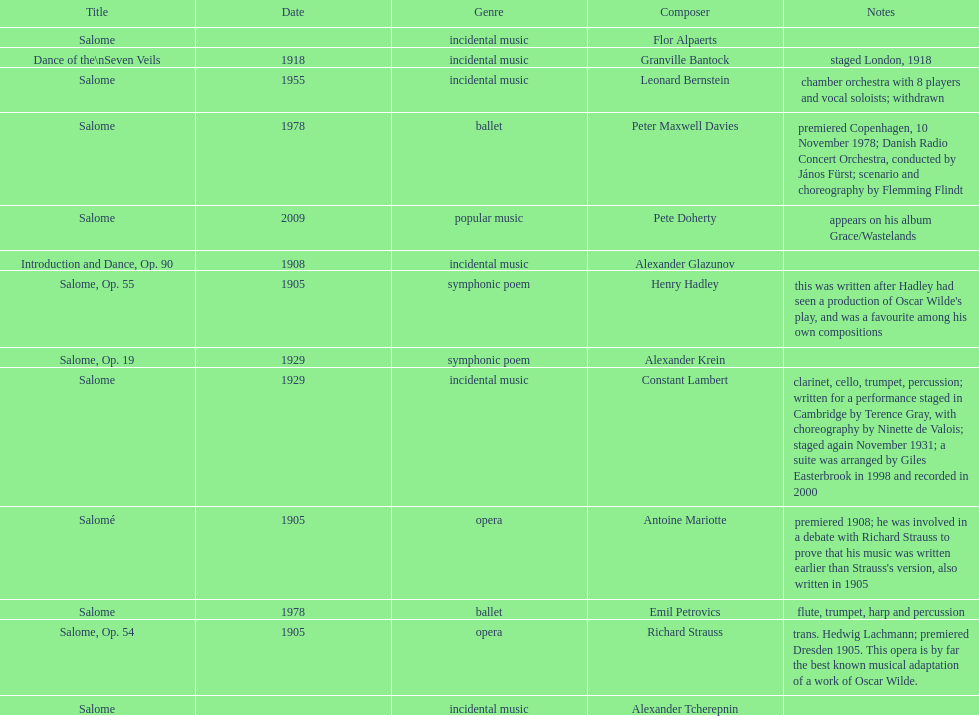Which composer is listed below pete doherty? Alexander Glazunov. 